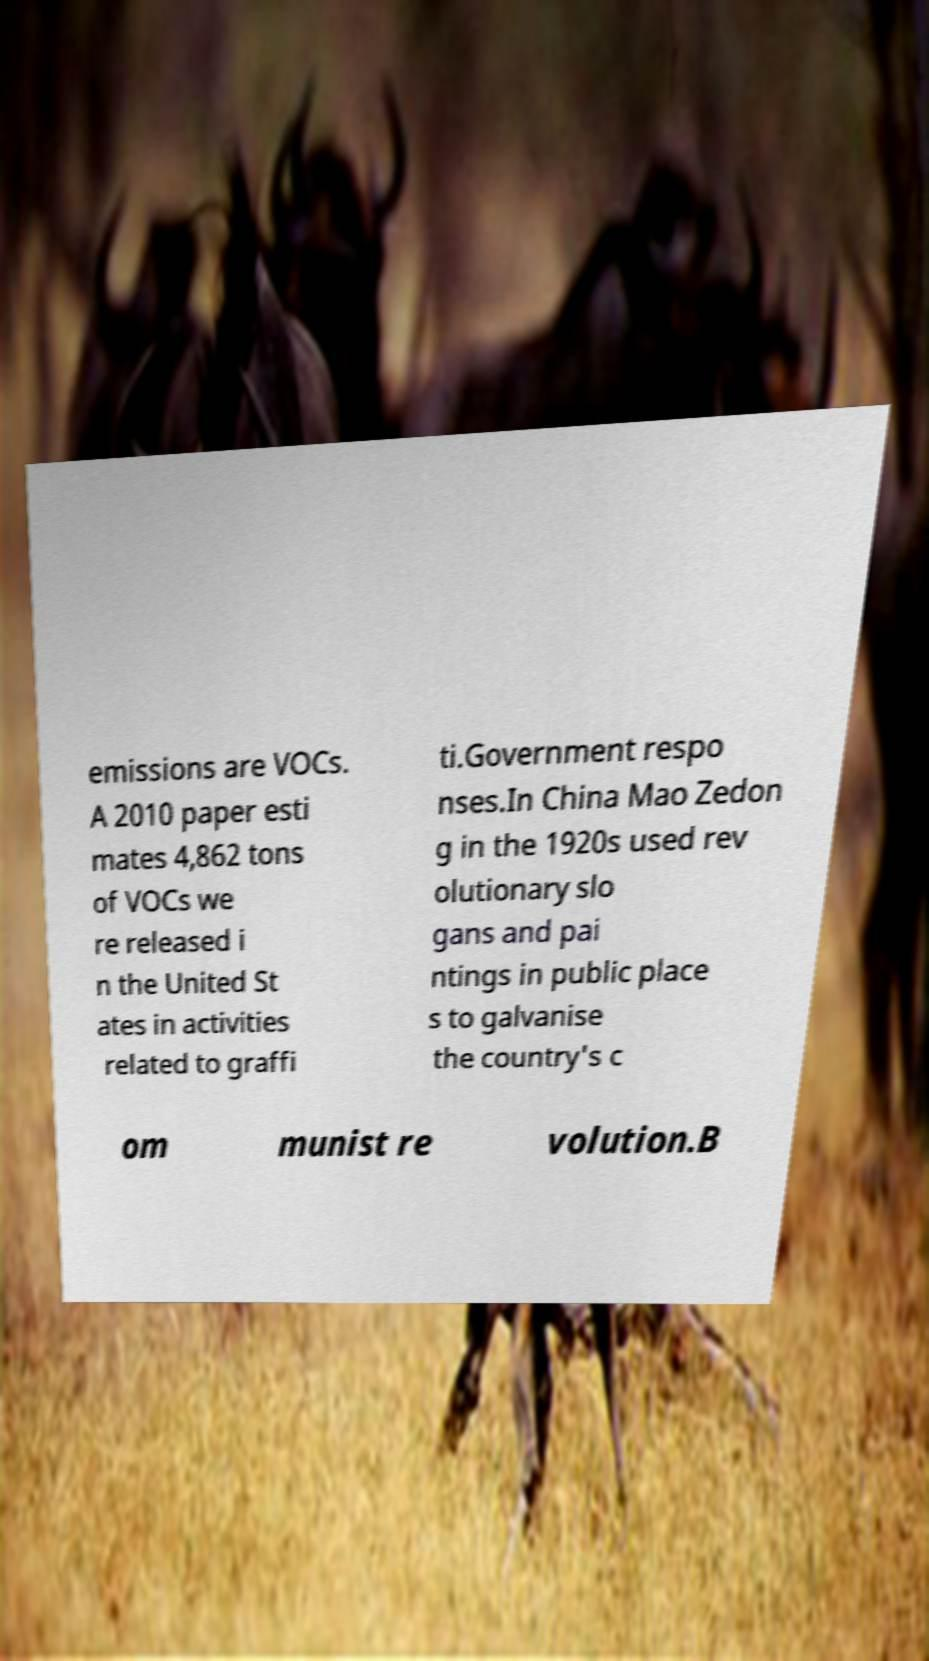Please identify and transcribe the text found in this image. emissions are VOCs. A 2010 paper esti mates 4,862 tons of VOCs we re released i n the United St ates in activities related to graffi ti.Government respo nses.In China Mao Zedon g in the 1920s used rev olutionary slo gans and pai ntings in public place s to galvanise the country's c om munist re volution.B 